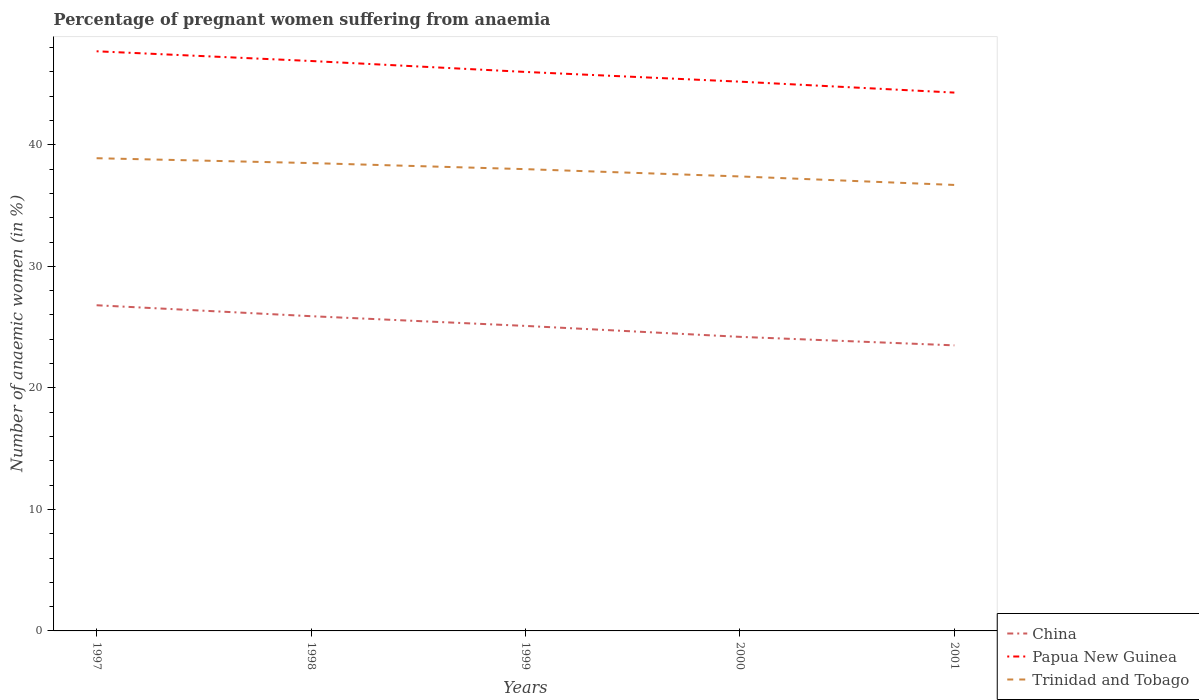Does the line corresponding to China intersect with the line corresponding to Papua New Guinea?
Provide a short and direct response. No. Is the number of lines equal to the number of legend labels?
Your answer should be very brief. Yes. Across all years, what is the maximum number of anaemic women in Trinidad and Tobago?
Your answer should be very brief. 36.7. What is the total number of anaemic women in Papua New Guinea in the graph?
Keep it short and to the point. 0.9. What is the difference between the highest and the second highest number of anaemic women in Papua New Guinea?
Keep it short and to the point. 3.4. What is the difference between the highest and the lowest number of anaemic women in China?
Your answer should be compact. 2. How many years are there in the graph?
Keep it short and to the point. 5. What is the difference between two consecutive major ticks on the Y-axis?
Offer a terse response. 10. Are the values on the major ticks of Y-axis written in scientific E-notation?
Your response must be concise. No. Does the graph contain any zero values?
Provide a succinct answer. No. Where does the legend appear in the graph?
Make the answer very short. Bottom right. What is the title of the graph?
Give a very brief answer. Percentage of pregnant women suffering from anaemia. Does "Arab World" appear as one of the legend labels in the graph?
Offer a terse response. No. What is the label or title of the Y-axis?
Your response must be concise. Number of anaemic women (in %). What is the Number of anaemic women (in %) in China in 1997?
Provide a short and direct response. 26.8. What is the Number of anaemic women (in %) in Papua New Guinea in 1997?
Make the answer very short. 47.7. What is the Number of anaemic women (in %) of Trinidad and Tobago in 1997?
Keep it short and to the point. 38.9. What is the Number of anaemic women (in %) in China in 1998?
Keep it short and to the point. 25.9. What is the Number of anaemic women (in %) in Papua New Guinea in 1998?
Your response must be concise. 46.9. What is the Number of anaemic women (in %) of Trinidad and Tobago in 1998?
Keep it short and to the point. 38.5. What is the Number of anaemic women (in %) in China in 1999?
Provide a short and direct response. 25.1. What is the Number of anaemic women (in %) in Trinidad and Tobago in 1999?
Provide a short and direct response. 38. What is the Number of anaemic women (in %) of China in 2000?
Provide a succinct answer. 24.2. What is the Number of anaemic women (in %) of Papua New Guinea in 2000?
Your answer should be compact. 45.2. What is the Number of anaemic women (in %) in Trinidad and Tobago in 2000?
Provide a succinct answer. 37.4. What is the Number of anaemic women (in %) in China in 2001?
Your response must be concise. 23.5. What is the Number of anaemic women (in %) in Papua New Guinea in 2001?
Your answer should be compact. 44.3. What is the Number of anaemic women (in %) of Trinidad and Tobago in 2001?
Provide a succinct answer. 36.7. Across all years, what is the maximum Number of anaemic women (in %) of China?
Provide a short and direct response. 26.8. Across all years, what is the maximum Number of anaemic women (in %) in Papua New Guinea?
Your answer should be very brief. 47.7. Across all years, what is the maximum Number of anaemic women (in %) in Trinidad and Tobago?
Make the answer very short. 38.9. Across all years, what is the minimum Number of anaemic women (in %) of Papua New Guinea?
Your response must be concise. 44.3. Across all years, what is the minimum Number of anaemic women (in %) of Trinidad and Tobago?
Ensure brevity in your answer.  36.7. What is the total Number of anaemic women (in %) in China in the graph?
Provide a short and direct response. 125.5. What is the total Number of anaemic women (in %) of Papua New Guinea in the graph?
Provide a short and direct response. 230.1. What is the total Number of anaemic women (in %) of Trinidad and Tobago in the graph?
Offer a very short reply. 189.5. What is the difference between the Number of anaemic women (in %) of China in 1997 and that in 1998?
Make the answer very short. 0.9. What is the difference between the Number of anaemic women (in %) of Papua New Guinea in 1997 and that in 1998?
Make the answer very short. 0.8. What is the difference between the Number of anaemic women (in %) of Papua New Guinea in 1997 and that in 1999?
Make the answer very short. 1.7. What is the difference between the Number of anaemic women (in %) of China in 1997 and that in 2000?
Provide a short and direct response. 2.6. What is the difference between the Number of anaemic women (in %) in China in 1997 and that in 2001?
Make the answer very short. 3.3. What is the difference between the Number of anaemic women (in %) in Papua New Guinea in 1997 and that in 2001?
Your answer should be very brief. 3.4. What is the difference between the Number of anaemic women (in %) in China in 1998 and that in 1999?
Ensure brevity in your answer.  0.8. What is the difference between the Number of anaemic women (in %) of Trinidad and Tobago in 1998 and that in 1999?
Offer a very short reply. 0.5. What is the difference between the Number of anaemic women (in %) in China in 1998 and that in 2000?
Provide a succinct answer. 1.7. What is the difference between the Number of anaemic women (in %) of Trinidad and Tobago in 1998 and that in 2000?
Provide a short and direct response. 1.1. What is the difference between the Number of anaemic women (in %) in China in 1998 and that in 2001?
Offer a terse response. 2.4. What is the difference between the Number of anaemic women (in %) in Papua New Guinea in 1998 and that in 2001?
Ensure brevity in your answer.  2.6. What is the difference between the Number of anaemic women (in %) of Trinidad and Tobago in 1998 and that in 2001?
Your answer should be compact. 1.8. What is the difference between the Number of anaemic women (in %) in China in 1999 and that in 2000?
Provide a succinct answer. 0.9. What is the difference between the Number of anaemic women (in %) of China in 2000 and that in 2001?
Offer a terse response. 0.7. What is the difference between the Number of anaemic women (in %) in Papua New Guinea in 2000 and that in 2001?
Offer a very short reply. 0.9. What is the difference between the Number of anaemic women (in %) of China in 1997 and the Number of anaemic women (in %) of Papua New Guinea in 1998?
Offer a very short reply. -20.1. What is the difference between the Number of anaemic women (in %) in China in 1997 and the Number of anaemic women (in %) in Papua New Guinea in 1999?
Keep it short and to the point. -19.2. What is the difference between the Number of anaemic women (in %) in China in 1997 and the Number of anaemic women (in %) in Papua New Guinea in 2000?
Ensure brevity in your answer.  -18.4. What is the difference between the Number of anaemic women (in %) in China in 1997 and the Number of anaemic women (in %) in Trinidad and Tobago in 2000?
Give a very brief answer. -10.6. What is the difference between the Number of anaemic women (in %) of China in 1997 and the Number of anaemic women (in %) of Papua New Guinea in 2001?
Provide a succinct answer. -17.5. What is the difference between the Number of anaemic women (in %) of China in 1997 and the Number of anaemic women (in %) of Trinidad and Tobago in 2001?
Give a very brief answer. -9.9. What is the difference between the Number of anaemic women (in %) of Papua New Guinea in 1997 and the Number of anaemic women (in %) of Trinidad and Tobago in 2001?
Offer a terse response. 11. What is the difference between the Number of anaemic women (in %) of China in 1998 and the Number of anaemic women (in %) of Papua New Guinea in 1999?
Provide a succinct answer. -20.1. What is the difference between the Number of anaemic women (in %) of China in 1998 and the Number of anaemic women (in %) of Trinidad and Tobago in 1999?
Your response must be concise. -12.1. What is the difference between the Number of anaemic women (in %) in China in 1998 and the Number of anaemic women (in %) in Papua New Guinea in 2000?
Ensure brevity in your answer.  -19.3. What is the difference between the Number of anaemic women (in %) of China in 1998 and the Number of anaemic women (in %) of Trinidad and Tobago in 2000?
Give a very brief answer. -11.5. What is the difference between the Number of anaemic women (in %) of China in 1998 and the Number of anaemic women (in %) of Papua New Guinea in 2001?
Your answer should be very brief. -18.4. What is the difference between the Number of anaemic women (in %) of Papua New Guinea in 1998 and the Number of anaemic women (in %) of Trinidad and Tobago in 2001?
Provide a short and direct response. 10.2. What is the difference between the Number of anaemic women (in %) of China in 1999 and the Number of anaemic women (in %) of Papua New Guinea in 2000?
Your answer should be very brief. -20.1. What is the difference between the Number of anaemic women (in %) of China in 1999 and the Number of anaemic women (in %) of Trinidad and Tobago in 2000?
Ensure brevity in your answer.  -12.3. What is the difference between the Number of anaemic women (in %) in China in 1999 and the Number of anaemic women (in %) in Papua New Guinea in 2001?
Provide a short and direct response. -19.2. What is the difference between the Number of anaemic women (in %) of Papua New Guinea in 1999 and the Number of anaemic women (in %) of Trinidad and Tobago in 2001?
Give a very brief answer. 9.3. What is the difference between the Number of anaemic women (in %) in China in 2000 and the Number of anaemic women (in %) in Papua New Guinea in 2001?
Give a very brief answer. -20.1. What is the difference between the Number of anaemic women (in %) of Papua New Guinea in 2000 and the Number of anaemic women (in %) of Trinidad and Tobago in 2001?
Ensure brevity in your answer.  8.5. What is the average Number of anaemic women (in %) of China per year?
Ensure brevity in your answer.  25.1. What is the average Number of anaemic women (in %) in Papua New Guinea per year?
Provide a succinct answer. 46.02. What is the average Number of anaemic women (in %) of Trinidad and Tobago per year?
Provide a succinct answer. 37.9. In the year 1997, what is the difference between the Number of anaemic women (in %) of China and Number of anaemic women (in %) of Papua New Guinea?
Provide a short and direct response. -20.9. In the year 1998, what is the difference between the Number of anaemic women (in %) of Papua New Guinea and Number of anaemic women (in %) of Trinidad and Tobago?
Make the answer very short. 8.4. In the year 1999, what is the difference between the Number of anaemic women (in %) in China and Number of anaemic women (in %) in Papua New Guinea?
Your response must be concise. -20.9. In the year 2000, what is the difference between the Number of anaemic women (in %) of China and Number of anaemic women (in %) of Trinidad and Tobago?
Your answer should be compact. -13.2. In the year 2001, what is the difference between the Number of anaemic women (in %) in China and Number of anaemic women (in %) in Papua New Guinea?
Provide a short and direct response. -20.8. In the year 2001, what is the difference between the Number of anaemic women (in %) in China and Number of anaemic women (in %) in Trinidad and Tobago?
Your answer should be compact. -13.2. What is the ratio of the Number of anaemic women (in %) in China in 1997 to that in 1998?
Your answer should be very brief. 1.03. What is the ratio of the Number of anaemic women (in %) in Papua New Guinea in 1997 to that in 1998?
Provide a short and direct response. 1.02. What is the ratio of the Number of anaemic women (in %) of Trinidad and Tobago in 1997 to that in 1998?
Your response must be concise. 1.01. What is the ratio of the Number of anaemic women (in %) of China in 1997 to that in 1999?
Provide a succinct answer. 1.07. What is the ratio of the Number of anaemic women (in %) of Papua New Guinea in 1997 to that in 1999?
Offer a terse response. 1.04. What is the ratio of the Number of anaemic women (in %) of Trinidad and Tobago in 1997 to that in 1999?
Your answer should be compact. 1.02. What is the ratio of the Number of anaemic women (in %) in China in 1997 to that in 2000?
Provide a short and direct response. 1.11. What is the ratio of the Number of anaemic women (in %) in Papua New Guinea in 1997 to that in 2000?
Provide a short and direct response. 1.06. What is the ratio of the Number of anaemic women (in %) of Trinidad and Tobago in 1997 to that in 2000?
Provide a short and direct response. 1.04. What is the ratio of the Number of anaemic women (in %) of China in 1997 to that in 2001?
Provide a short and direct response. 1.14. What is the ratio of the Number of anaemic women (in %) in Papua New Guinea in 1997 to that in 2001?
Make the answer very short. 1.08. What is the ratio of the Number of anaemic women (in %) in Trinidad and Tobago in 1997 to that in 2001?
Offer a terse response. 1.06. What is the ratio of the Number of anaemic women (in %) of China in 1998 to that in 1999?
Keep it short and to the point. 1.03. What is the ratio of the Number of anaemic women (in %) in Papua New Guinea in 1998 to that in 1999?
Your answer should be very brief. 1.02. What is the ratio of the Number of anaemic women (in %) in Trinidad and Tobago in 1998 to that in 1999?
Offer a terse response. 1.01. What is the ratio of the Number of anaemic women (in %) of China in 1998 to that in 2000?
Offer a terse response. 1.07. What is the ratio of the Number of anaemic women (in %) of Papua New Guinea in 1998 to that in 2000?
Offer a very short reply. 1.04. What is the ratio of the Number of anaemic women (in %) in Trinidad and Tobago in 1998 to that in 2000?
Make the answer very short. 1.03. What is the ratio of the Number of anaemic women (in %) in China in 1998 to that in 2001?
Your answer should be very brief. 1.1. What is the ratio of the Number of anaemic women (in %) in Papua New Guinea in 1998 to that in 2001?
Make the answer very short. 1.06. What is the ratio of the Number of anaemic women (in %) of Trinidad and Tobago in 1998 to that in 2001?
Your response must be concise. 1.05. What is the ratio of the Number of anaemic women (in %) of China in 1999 to that in 2000?
Provide a succinct answer. 1.04. What is the ratio of the Number of anaemic women (in %) of Papua New Guinea in 1999 to that in 2000?
Offer a very short reply. 1.02. What is the ratio of the Number of anaemic women (in %) in Trinidad and Tobago in 1999 to that in 2000?
Your answer should be very brief. 1.02. What is the ratio of the Number of anaemic women (in %) of China in 1999 to that in 2001?
Provide a short and direct response. 1.07. What is the ratio of the Number of anaemic women (in %) of Papua New Guinea in 1999 to that in 2001?
Offer a terse response. 1.04. What is the ratio of the Number of anaemic women (in %) in Trinidad and Tobago in 1999 to that in 2001?
Provide a short and direct response. 1.04. What is the ratio of the Number of anaemic women (in %) of China in 2000 to that in 2001?
Keep it short and to the point. 1.03. What is the ratio of the Number of anaemic women (in %) in Papua New Guinea in 2000 to that in 2001?
Offer a very short reply. 1.02. What is the ratio of the Number of anaemic women (in %) in Trinidad and Tobago in 2000 to that in 2001?
Ensure brevity in your answer.  1.02. What is the difference between the highest and the second highest Number of anaemic women (in %) of Papua New Guinea?
Your answer should be very brief. 0.8. What is the difference between the highest and the second highest Number of anaemic women (in %) in Trinidad and Tobago?
Your answer should be compact. 0.4. What is the difference between the highest and the lowest Number of anaemic women (in %) of China?
Offer a very short reply. 3.3. What is the difference between the highest and the lowest Number of anaemic women (in %) in Papua New Guinea?
Your response must be concise. 3.4. 